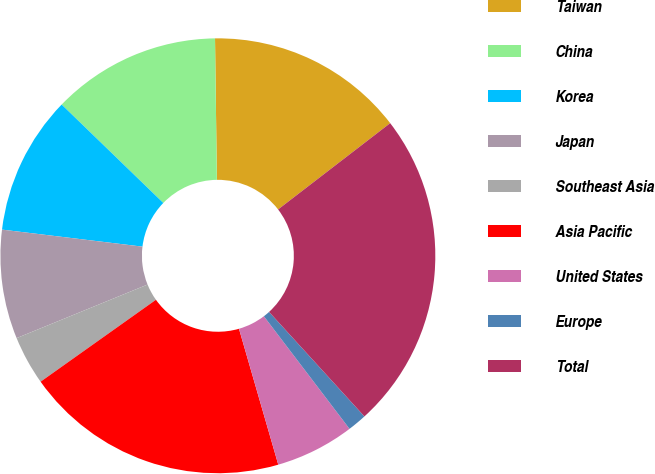<chart> <loc_0><loc_0><loc_500><loc_500><pie_chart><fcel>Taiwan<fcel>China<fcel>Korea<fcel>Japan<fcel>Southeast Asia<fcel>Asia Pacific<fcel>United States<fcel>Europe<fcel>Total<nl><fcel>14.77%<fcel>12.55%<fcel>10.32%<fcel>8.1%<fcel>3.65%<fcel>19.65%<fcel>5.87%<fcel>1.42%<fcel>23.67%<nl></chart> 